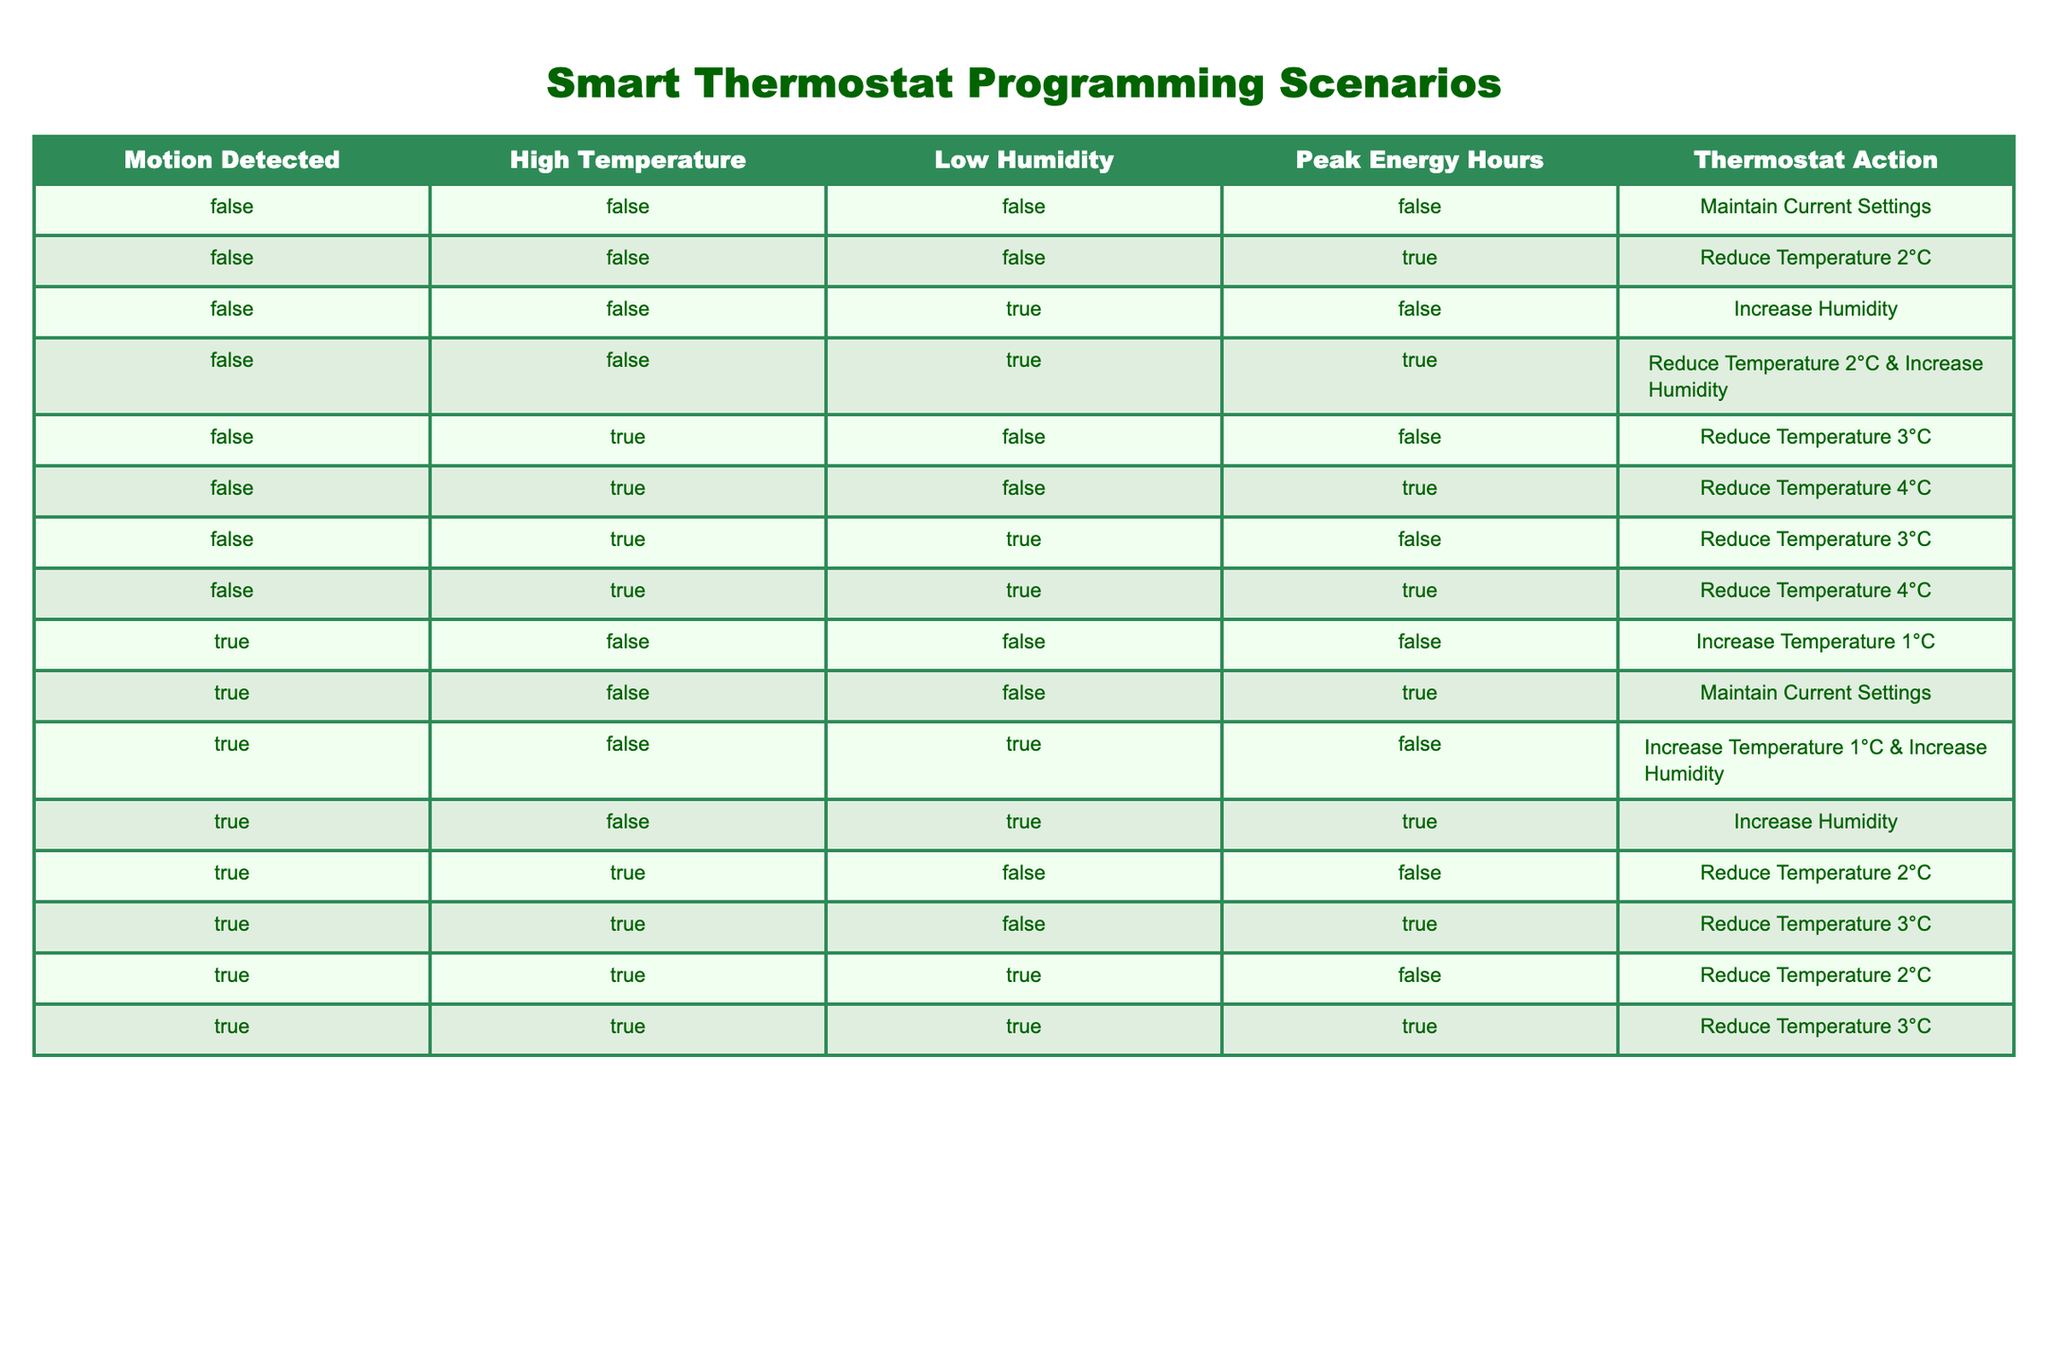What thermostat action occurs when motion is detected, high temperature, and low humidity all at false? According to the table, when Motion Detected is FALSE, High Temperature is FALSE, and Low Humidity is FALSE, the action is to Maintain Current Settings.
Answer: Maintain Current Settings What happens if the temperature is high during peak energy hours? The table shows that when High Temperature is TRUE during Peak Energy Hours, the thermostat reduces the temperature by either 3 or 4 degrees depending on the state of low humidity. The specific action depends on whether low humidity is true or false.
Answer: Reduce Temperature 3°C or Reduce Temperature 4°C Is there any action taken when low humidity is true, and peak energy hours are false with motion detected false? From the table, if low humidity is TRUE, peak energy hours are FALSE, and other conditions are FALSE, the thermostat's action is to Increase Humidity.
Answer: Increase Humidity How many unique thermostat actions are available in the table? By examining the actions listed in the table, we find that there are six unique actions: Maintain Current Settings, Reduce Temperature by 2°C, Reduce Temperature by 3°C, Reduce Temperature by 4°C, Increase Temperature by 1°C, and Increase Humidity.
Answer: Six What is the average temperature reduction when the motion is detected, high temperature is true, and humidity is low? In the scenarios where Motion Detected is TRUE and High Temperature is TRUE, the thermostat reduces the temperature by either 2°C or 3°C based on low humidity being FALSE or TRUE. The average reduction can be calculated as (2 + 3) / 2 = 2.5.
Answer: 2.5°C If motion is detected and low humidity is true, what is the action taken regarding temperature? When Motion Detected is TRUE and Low Humidity is TRUE, the actions are to either Increase Temperature by 1°C or Reduce Temperature by 2°C, depending on whether High Temperature is FALSE or TRUE. Therefore, the precise action can vary.
Answer: Varies (Increase Temperature 1°C or Reduce Temperature 2°C) Is it possible to reduce the temperature during peak energy hours when motion is detected? Yes, when motion is detected (TRUE), it is possible to have the thermostat reduce the temperature during peak energy hours (TRUE) under several conditions depending on humidity and temperature state.
Answer: Yes What is the total number of actions related to humidity increase in the table? Looking through the table, there are three instances where humidity is increased: Increase Humidity, Increase Humidity (with motion detected), and Increase Humidity (when humidity is false). Therefore, totaling these gives us 3 actions related to humidity increase.
Answer: Three 